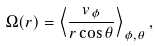Convert formula to latex. <formula><loc_0><loc_0><loc_500><loc_500>\Omega ( r ) = \left < \frac { v _ { \phi } } { r \cos { \theta } } \right > _ { \phi , \theta } ,</formula> 